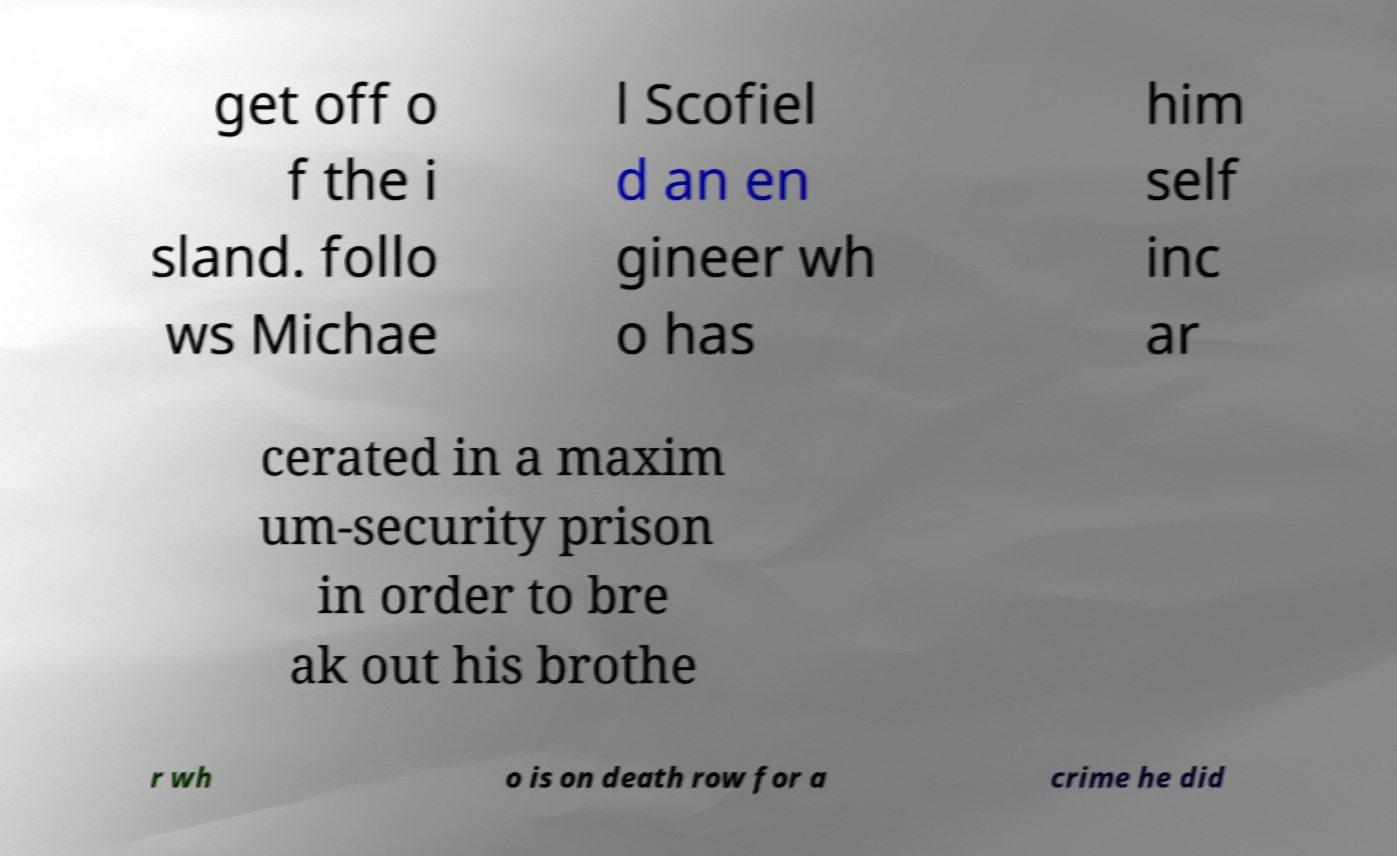Please identify and transcribe the text found in this image. get off o f the i sland. follo ws Michae l Scofiel d an en gineer wh o has him self inc ar cerated in a maxim um-security prison in order to bre ak out his brothe r wh o is on death row for a crime he did 